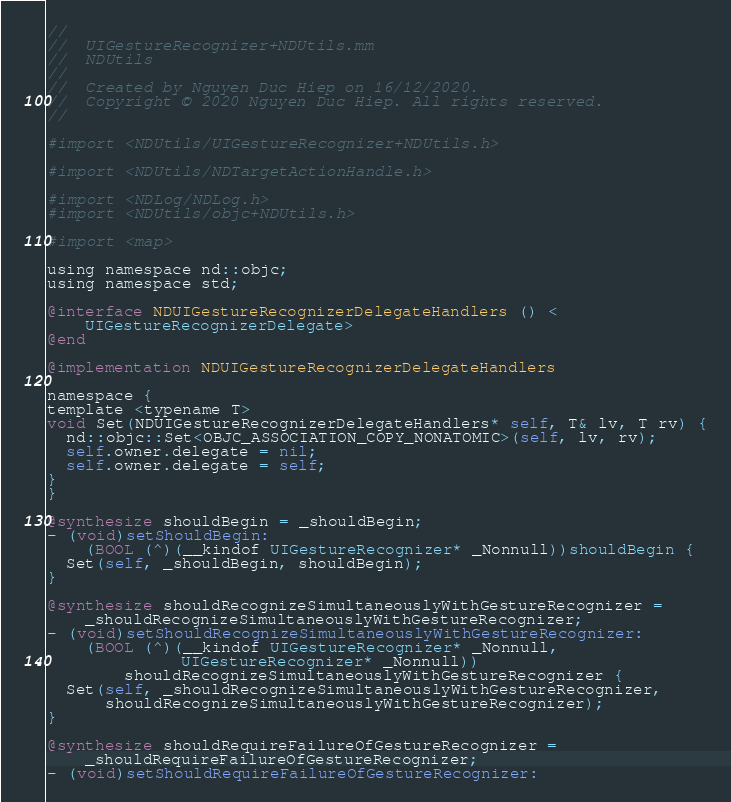<code> <loc_0><loc_0><loc_500><loc_500><_ObjectiveC_>//
//  UIGestureRecognizer+NDUtils.mm
//  NDUtils
//
//  Created by Nguyen Duc Hiep on 16/12/2020.
//  Copyright © 2020 Nguyen Duc Hiep. All rights reserved.
//

#import <NDUtils/UIGestureRecognizer+NDUtils.h>

#import <NDUtils/NDTargetActionHandle.h>

#import <NDLog/NDLog.h>
#import <NDUtils/objc+NDUtils.h>

#import <map>

using namespace nd::objc;
using namespace std;

@interface NDUIGestureRecognizerDelegateHandlers () <
    UIGestureRecognizerDelegate>
@end

@implementation NDUIGestureRecognizerDelegateHandlers

namespace {
template <typename T>
void Set(NDUIGestureRecognizerDelegateHandlers* self, T& lv, T rv) {
  nd::objc::Set<OBJC_ASSOCIATION_COPY_NONATOMIC>(self, lv, rv);
  self.owner.delegate = nil;
  self.owner.delegate = self;
}
}

@synthesize shouldBegin = _shouldBegin;
- (void)setShouldBegin:
    (BOOL (^)(__kindof UIGestureRecognizer* _Nonnull))shouldBegin {
  Set(self, _shouldBegin, shouldBegin);
}

@synthesize shouldRecognizeSimultaneouslyWithGestureRecognizer =
    _shouldRecognizeSimultaneouslyWithGestureRecognizer;
- (void)setShouldRecognizeSimultaneouslyWithGestureRecognizer:
    (BOOL (^)(__kindof UIGestureRecognizer* _Nonnull,
              UIGestureRecognizer* _Nonnull))
        shouldRecognizeSimultaneouslyWithGestureRecognizer {
  Set(self, _shouldRecognizeSimultaneouslyWithGestureRecognizer,
      shouldRecognizeSimultaneouslyWithGestureRecognizer);
}

@synthesize shouldRequireFailureOfGestureRecognizer =
    _shouldRequireFailureOfGestureRecognizer;
- (void)setShouldRequireFailureOfGestureRecognizer:</code> 